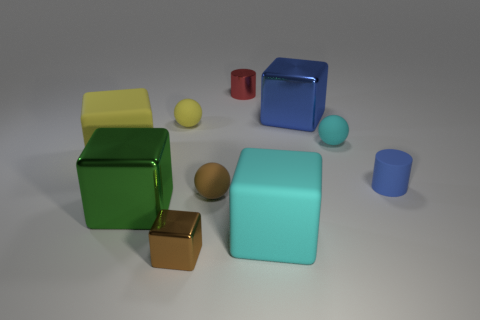What material is the tiny red object?
Give a very brief answer. Metal. Are there any green objects in front of the large green object?
Provide a short and direct response. No. Do the small brown metal object and the big blue object have the same shape?
Keep it short and to the point. Yes. What number of other objects are the same size as the cyan cube?
Provide a succinct answer. 3. How many things are large shiny blocks that are right of the shiny cylinder or blocks?
Offer a terse response. 5. The tiny matte cylinder is what color?
Make the answer very short. Blue. What is the material of the small brown object right of the brown block?
Provide a succinct answer. Rubber. Is the shape of the large blue object the same as the cyan matte object that is in front of the blue rubber cylinder?
Give a very brief answer. Yes. Is the number of small red rubber cubes greater than the number of small metal cubes?
Your answer should be compact. No. Is there anything else of the same color as the tiny metallic cylinder?
Your answer should be compact. No. 